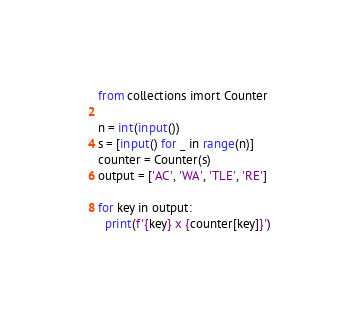Convert code to text. <code><loc_0><loc_0><loc_500><loc_500><_Python_>from collections imort Counter

n = int(input())
s = [input() for _ in range(n)]
counter = Counter(s)
output = ['AC', 'WA', 'TLE', 'RE']

for key in output:
  print(f'{key} x {counter[key]}')</code> 